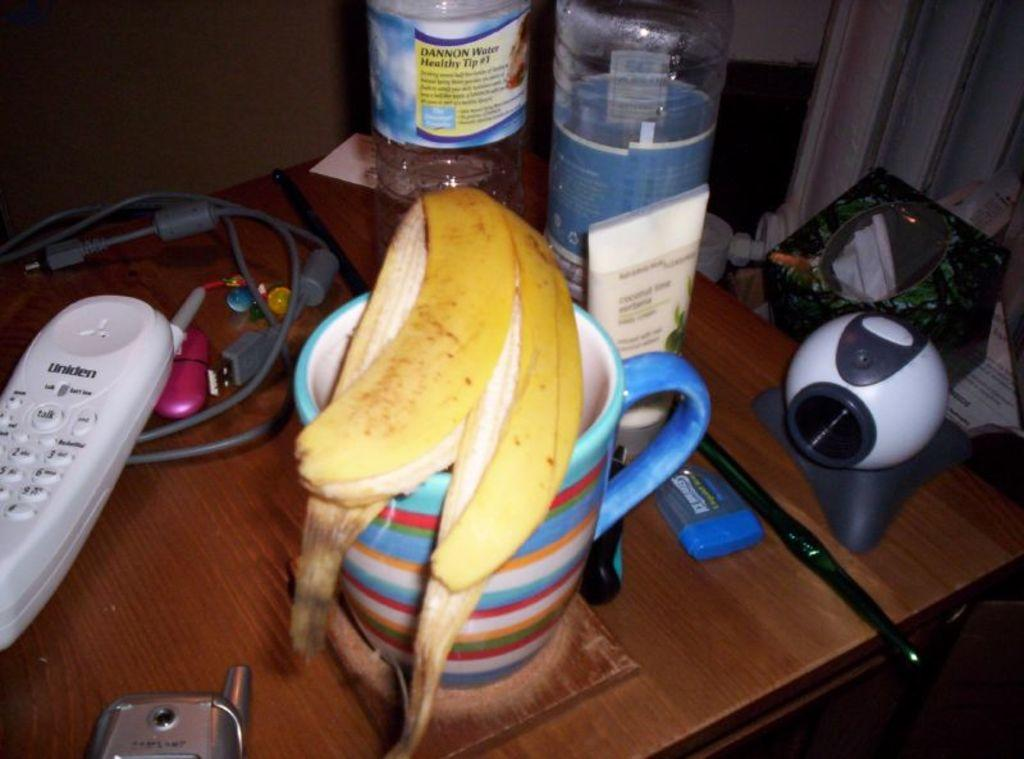<image>
Offer a succinct explanation of the picture presented. A phone that says Uniden next to a banana 